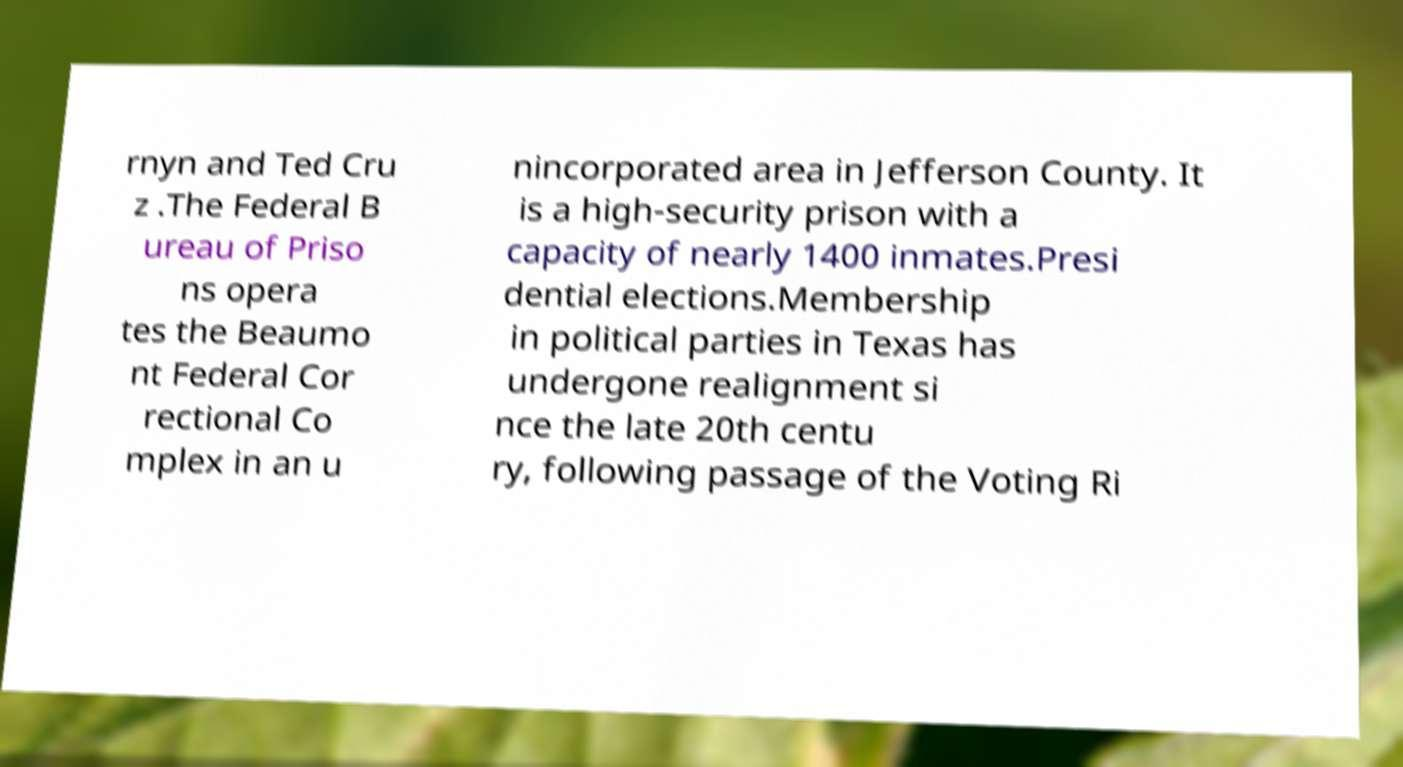Could you assist in decoding the text presented in this image and type it out clearly? rnyn and Ted Cru z .The Federal B ureau of Priso ns opera tes the Beaumo nt Federal Cor rectional Co mplex in an u nincorporated area in Jefferson County. It is a high-security prison with a capacity of nearly 1400 inmates.Presi dential elections.Membership in political parties in Texas has undergone realignment si nce the late 20th centu ry, following passage of the Voting Ri 